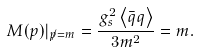Convert formula to latex. <formula><loc_0><loc_0><loc_500><loc_500>M ( p ) | _ { { \not p } = m } = \frac { g _ { s } ^ { 2 } \left \langle \bar { q } q \right \rangle } { 3 m ^ { 2 } } = m .</formula> 